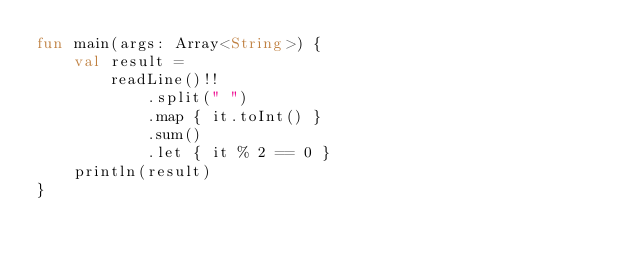Convert code to text. <code><loc_0><loc_0><loc_500><loc_500><_Kotlin_>fun main(args: Array<String>) {
    val result =
        readLine()!!
            .split(" ")
            .map { it.toInt() }
            .sum()
            .let { it % 2 == 0 }
    println(result)
}</code> 